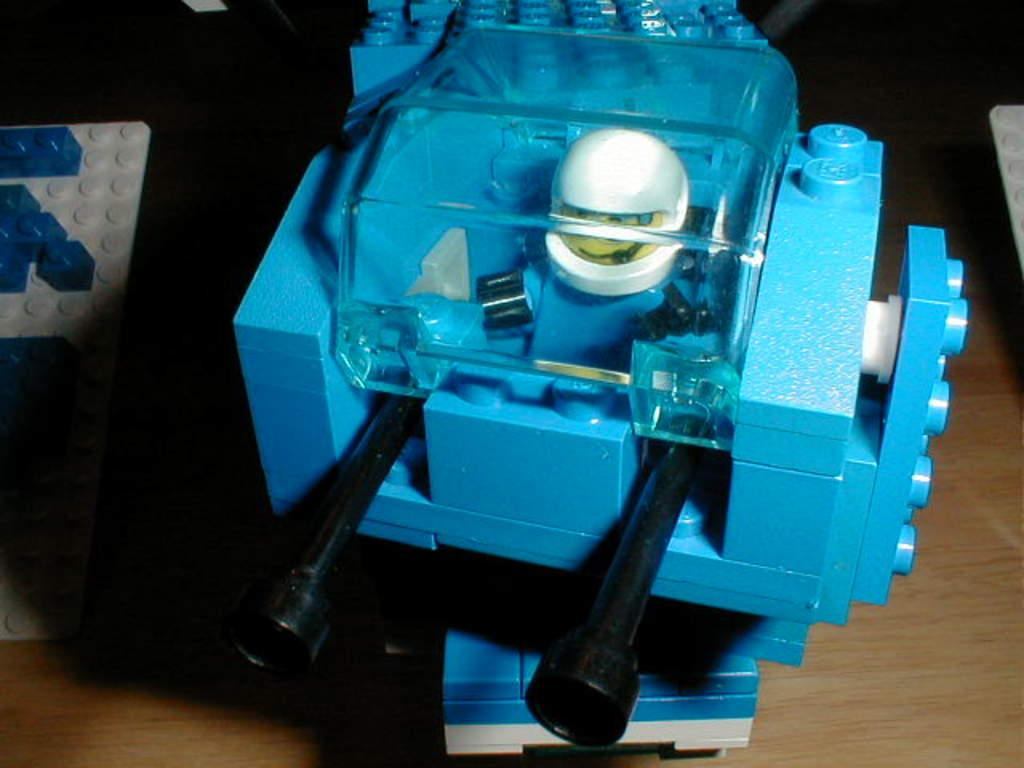What objects are present in the image? There are toys in the image. Where are the toys located? The toys are on a table. Are there any men or slaves depicted in the image? No, there are no men or slaves present in the image; it only features toys on a table. What type of yoke is being used by the toys in the image? There is no yoke present in the image; it only features toys on a table. 